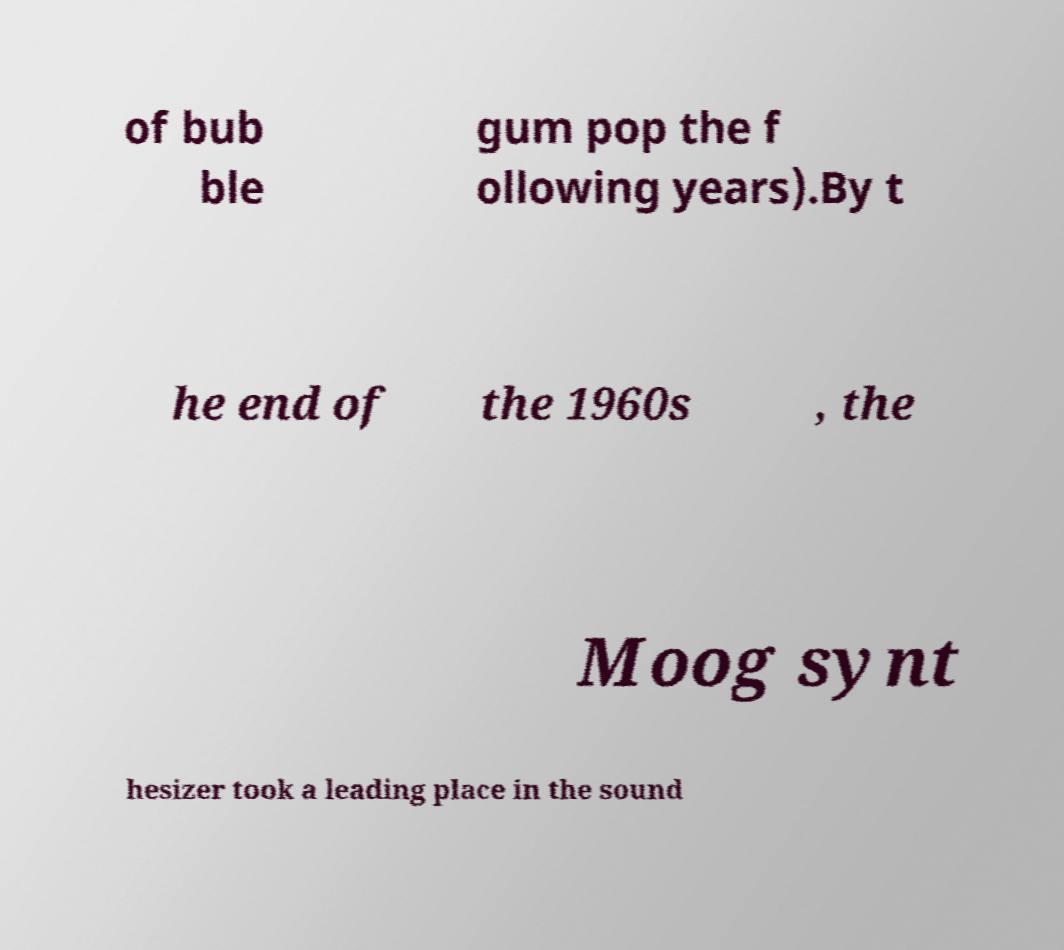What messages or text are displayed in this image? I need them in a readable, typed format. of bub ble gum pop the f ollowing years).By t he end of the 1960s , the Moog synt hesizer took a leading place in the sound 